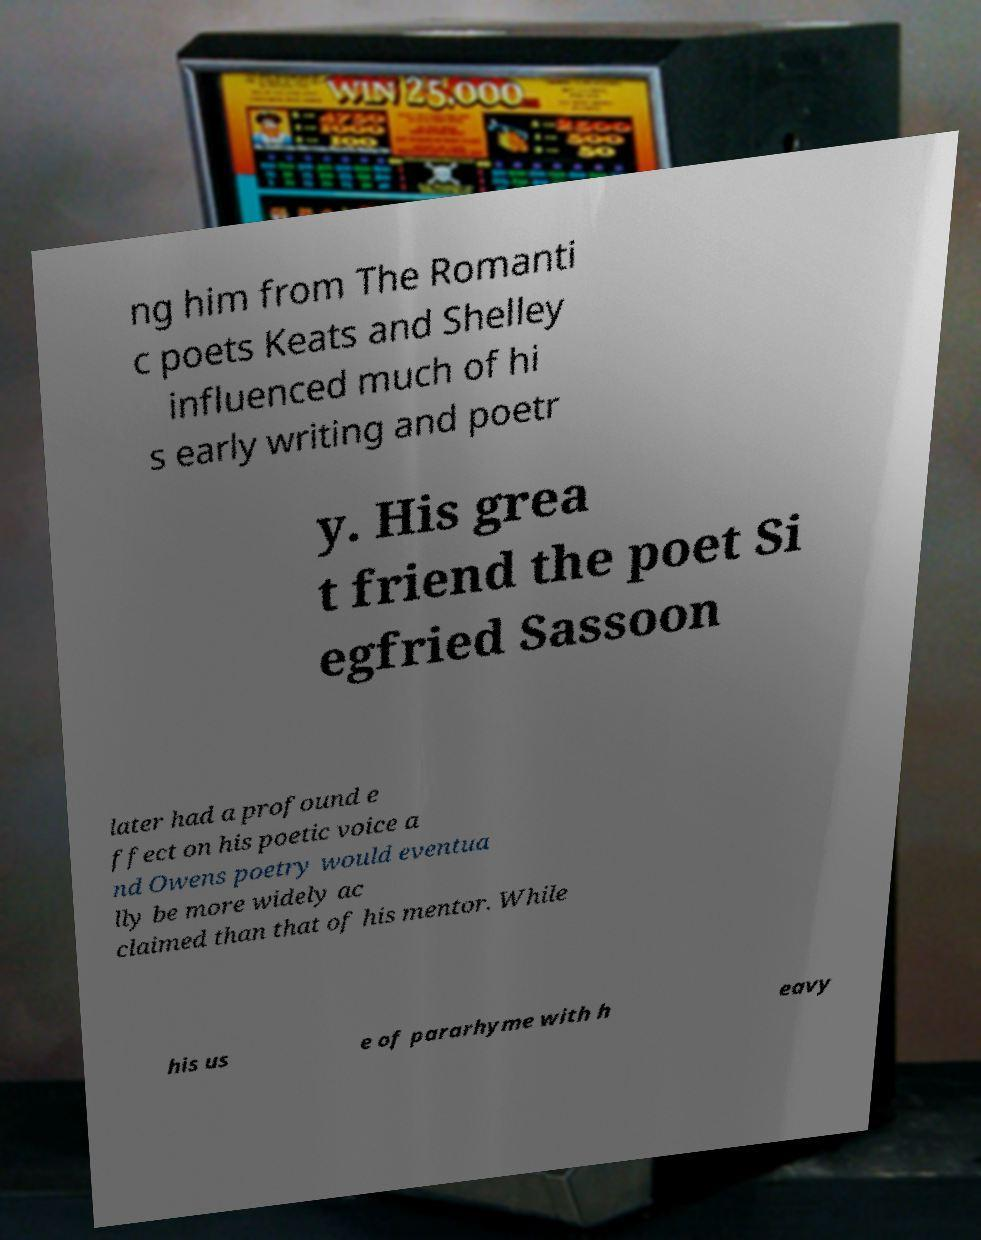For documentation purposes, I need the text within this image transcribed. Could you provide that? ng him from The Romanti c poets Keats and Shelley influenced much of hi s early writing and poetr y. His grea t friend the poet Si egfried Sassoon later had a profound e ffect on his poetic voice a nd Owens poetry would eventua lly be more widely ac claimed than that of his mentor. While his us e of pararhyme with h eavy 